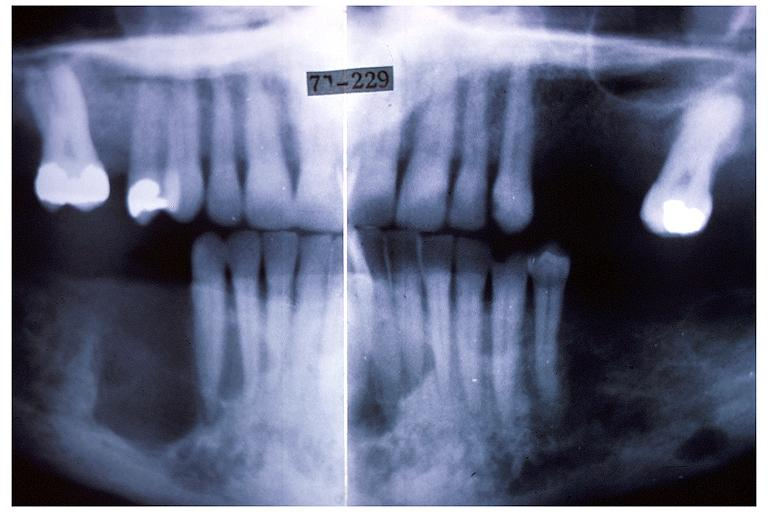does embryo-fetus show hyperparathyroidism brown tumor?
Answer the question using a single word or phrase. No 